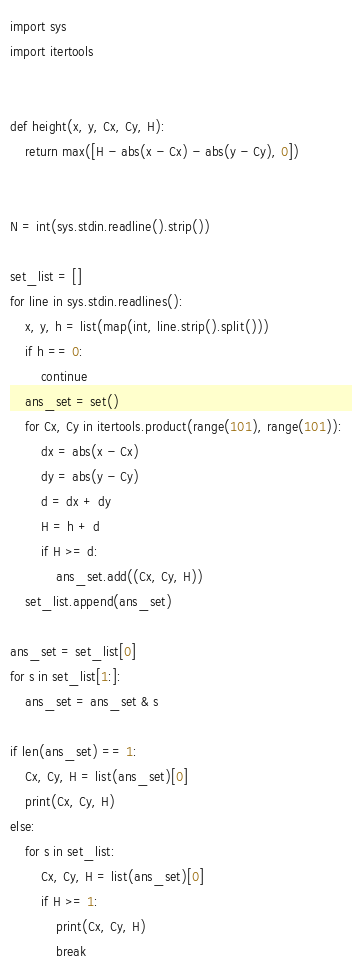<code> <loc_0><loc_0><loc_500><loc_500><_Python_>import sys
import itertools


def height(x, y, Cx, Cy, H):
    return max([H - abs(x - Cx) - abs(y - Cy), 0])


N = int(sys.stdin.readline().strip())

set_list = []
for line in sys.stdin.readlines():
    x, y, h = list(map(int, line.strip().split()))
    if h == 0:
        continue
    ans_set = set()
    for Cx, Cy in itertools.product(range(101), range(101)):
        dx = abs(x - Cx)
        dy = abs(y - Cy)
        d = dx + dy
        H = h + d
        if H >= d:
            ans_set.add((Cx, Cy, H))
    set_list.append(ans_set)

ans_set = set_list[0]
for s in set_list[1:]:
    ans_set = ans_set & s

if len(ans_set) == 1:
    Cx, Cy, H = list(ans_set)[0]
    print(Cx, Cy, H)
else:
    for s in set_list:
        Cx, Cy, H = list(ans_set)[0]
        if H >= 1:
            print(Cx, Cy, H)
            break
</code> 